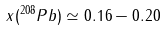<formula> <loc_0><loc_0><loc_500><loc_500>x ( ^ { 2 0 8 } P b ) \simeq 0 . 1 6 - 0 . 2 0</formula> 